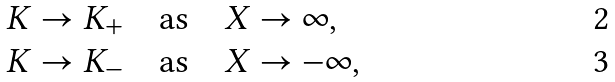Convert formula to latex. <formula><loc_0><loc_0><loc_500><loc_500>& K \to K _ { + } \quad \text {as} \quad X \to \infty , \\ & K \to K _ { - } \quad \text {as} \quad X \to - \infty ,</formula> 